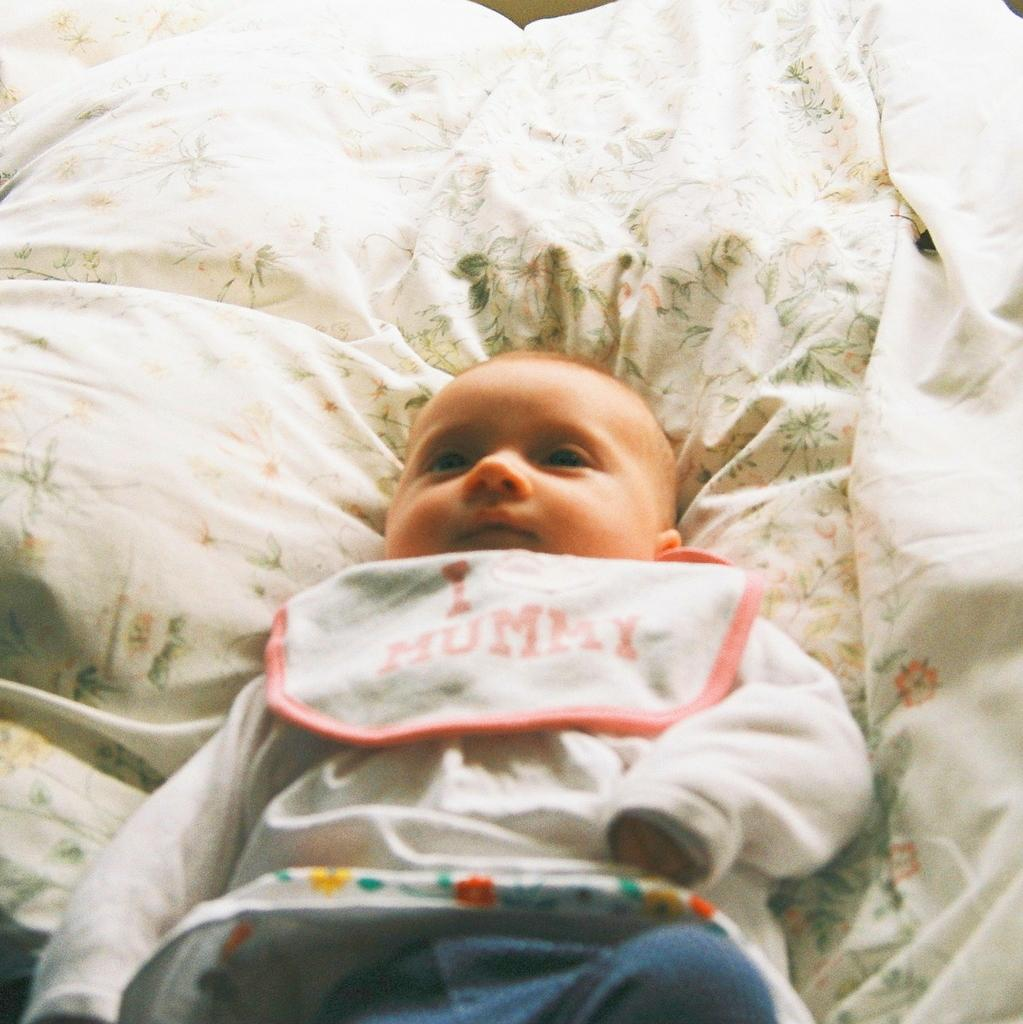What is the main subject of the image? The main subject of the image is a baby. What is the baby wearing in the image? The baby is wearing a dress in the image. Where is the baby located in the image? The baby is lying on a bed in the image. What type of jeans is the baby wearing in the image? The baby is not wearing jeans in the image; they are wearing a dress. Can you tell me what type of guitar the baby is playing in the image? There is no guitar present in the image; the baby is lying on a bed. 